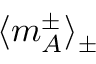<formula> <loc_0><loc_0><loc_500><loc_500>\langle m _ { A } ^ { \pm } \rangle _ { \pm }</formula> 